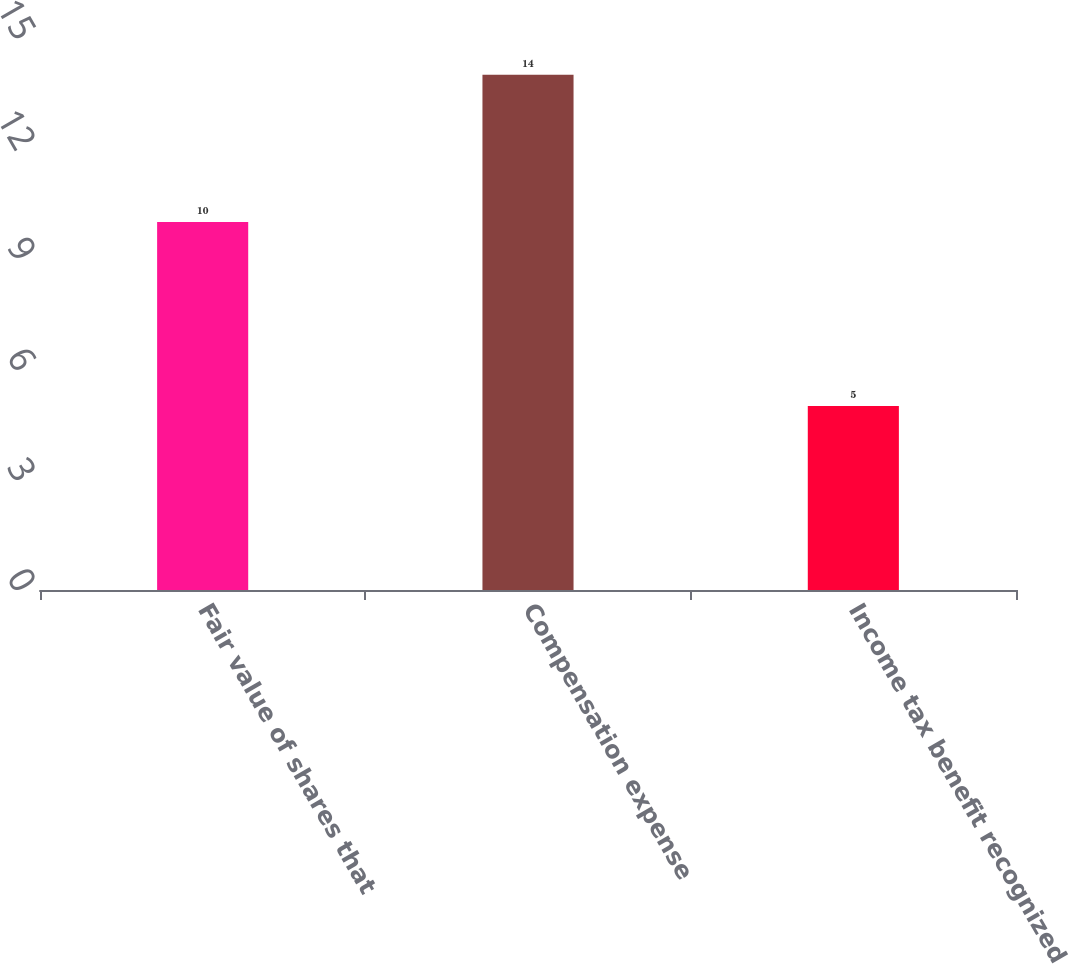<chart> <loc_0><loc_0><loc_500><loc_500><bar_chart><fcel>Fair value of shares that<fcel>Compensation expense<fcel>Income tax benefit recognized<nl><fcel>10<fcel>14<fcel>5<nl></chart> 